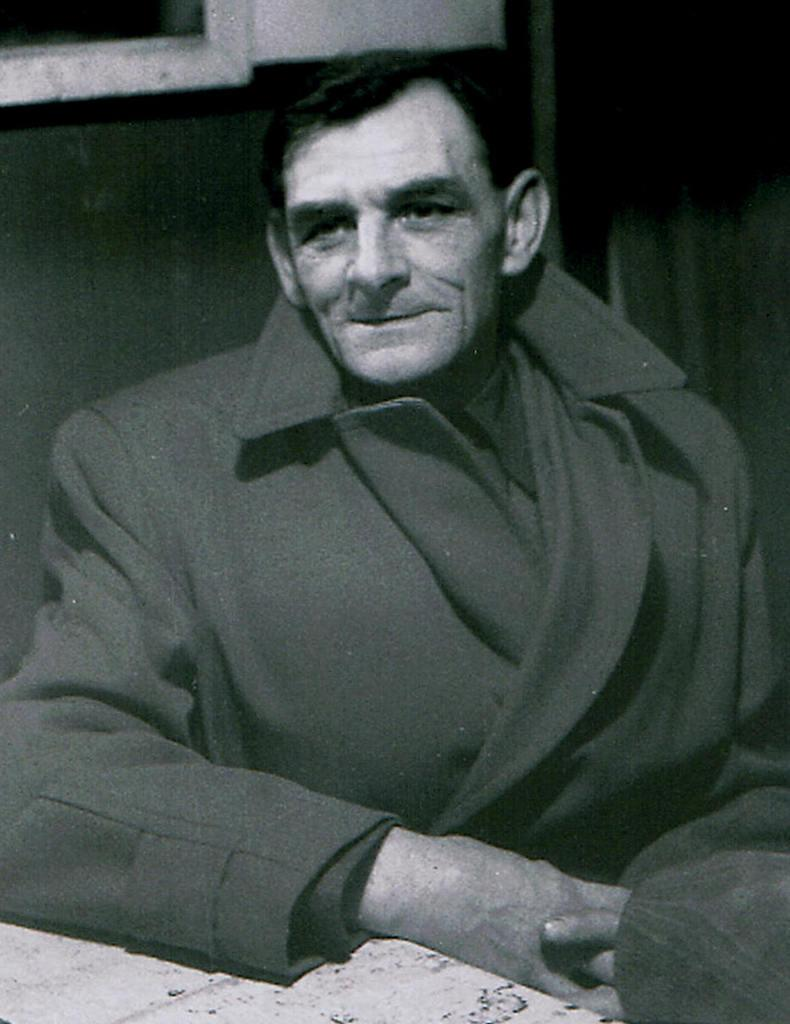Who is present in the image? There is a man in the image. What is the man doing in the image? The man is sitting in the image. What expression does the man have in the image? The man is smiling in the image. What is the color scheme of the image? The image is black and white in color. How many lizards can be seen crawling on the man's underwear in the image? There are no lizards or underwear present in the image, so this cannot be answered. 